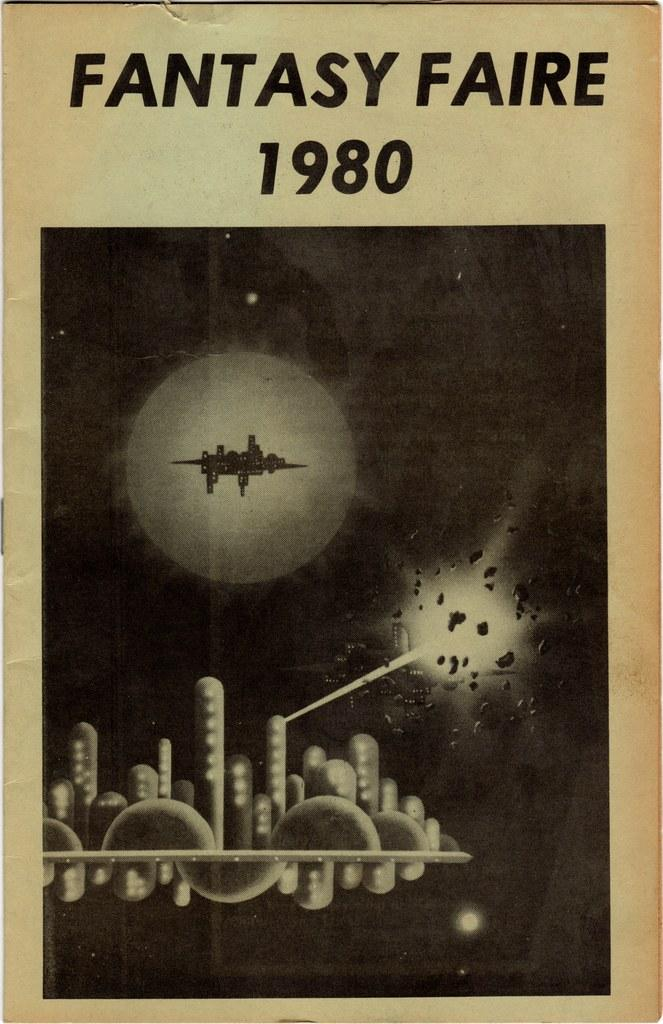What is present on the poster in the image? There is a poster in the image that contains text, numbers, and an image. What type of objects are animated in the image on the poster? The image on the poster contains animated objects. How many people are in the crowd depicted in the image on the poster? There is no crowd depicted in the image on the poster; it contains animated objects. What type of shade is provided by the snail in the image on the poster? There is no snail present in the image on the poster; it contains animated objects. 